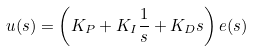<formula> <loc_0><loc_0><loc_500><loc_500>u ( s ) = \left ( K _ { P } + K _ { I } { \frac { 1 } { s } } + K _ { D } s \right ) e ( s )</formula> 